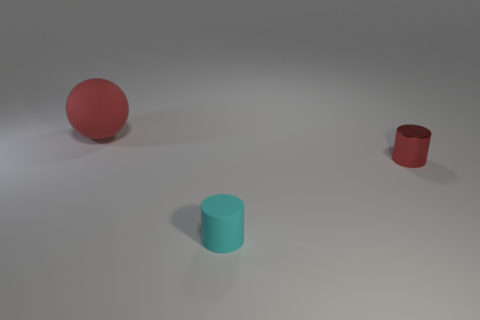Add 3 brown cylinders. How many objects exist? 6 Subtract all cylinders. How many objects are left? 1 Subtract all shiny cylinders. Subtract all cylinders. How many objects are left? 0 Add 2 small red shiny things. How many small red shiny things are left? 3 Add 3 gray matte cylinders. How many gray matte cylinders exist? 3 Subtract 1 red cylinders. How many objects are left? 2 